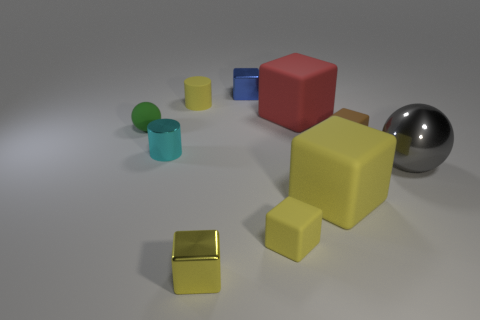Can you tell me the number of spheres present and their colors? There is a single sphere in the image, and it has a reflective silver surface.  And what about the cubes, how many are there and what do they look like? I see three cubes: one large red cube with a matte finish, a smaller yellow cube, and an even smaller gold cube with a reflective finish. 